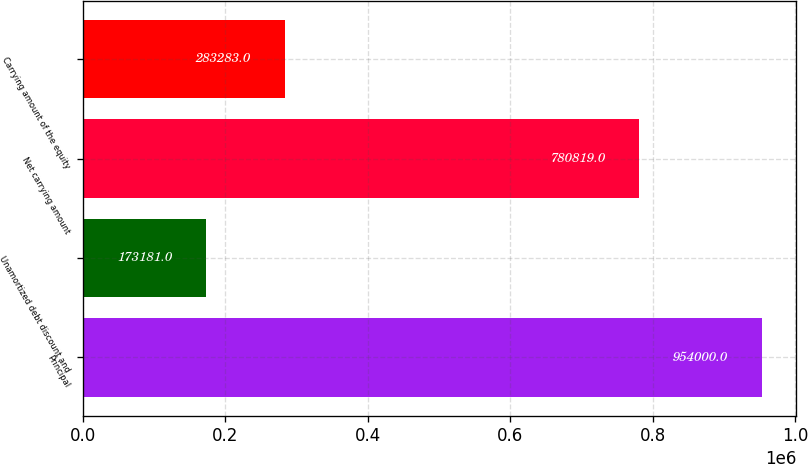<chart> <loc_0><loc_0><loc_500><loc_500><bar_chart><fcel>Principal<fcel>Unamortized debt discount and<fcel>Net carrying amount<fcel>Carrying amount of the equity<nl><fcel>954000<fcel>173181<fcel>780819<fcel>283283<nl></chart> 